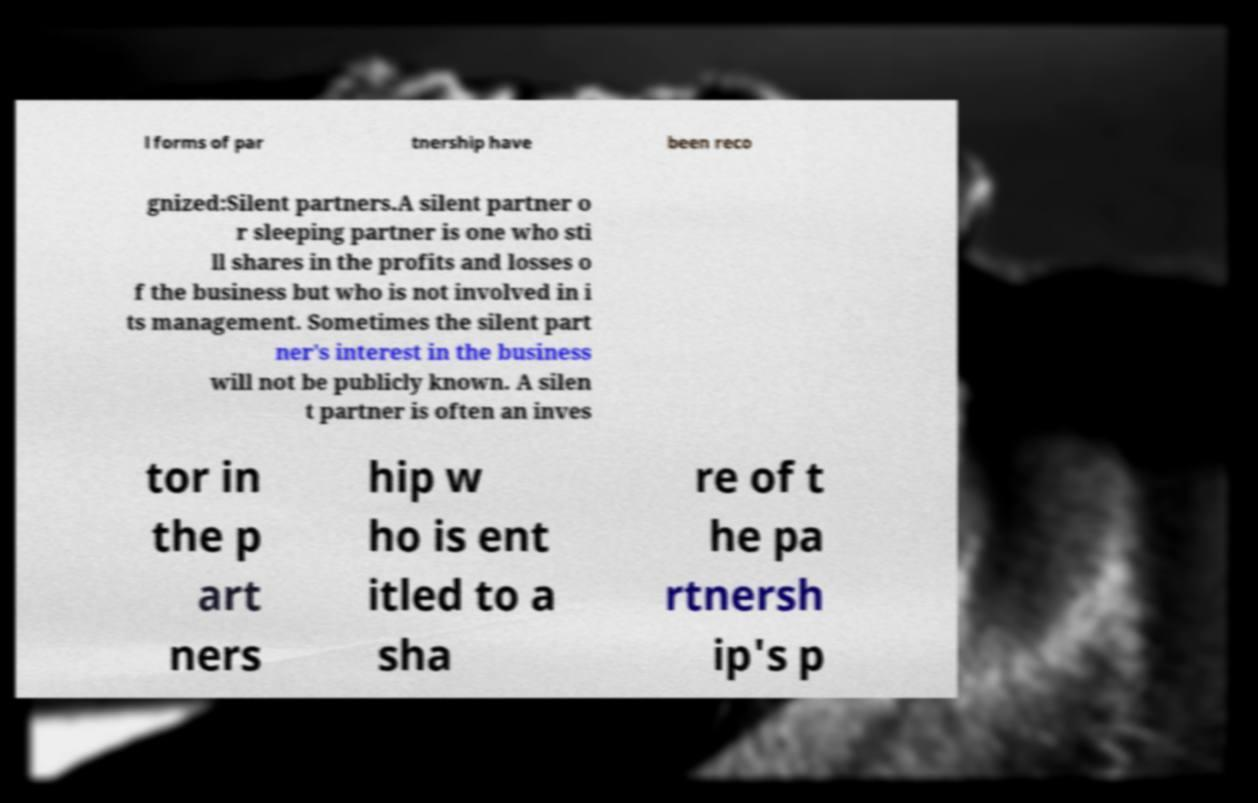For documentation purposes, I need the text within this image transcribed. Could you provide that? l forms of par tnership have been reco gnized:Silent partners.A silent partner o r sleeping partner is one who sti ll shares in the profits and losses o f the business but who is not involved in i ts management. Sometimes the silent part ner's interest in the business will not be publicly known. A silen t partner is often an inves tor in the p art ners hip w ho is ent itled to a sha re of t he pa rtnersh ip's p 